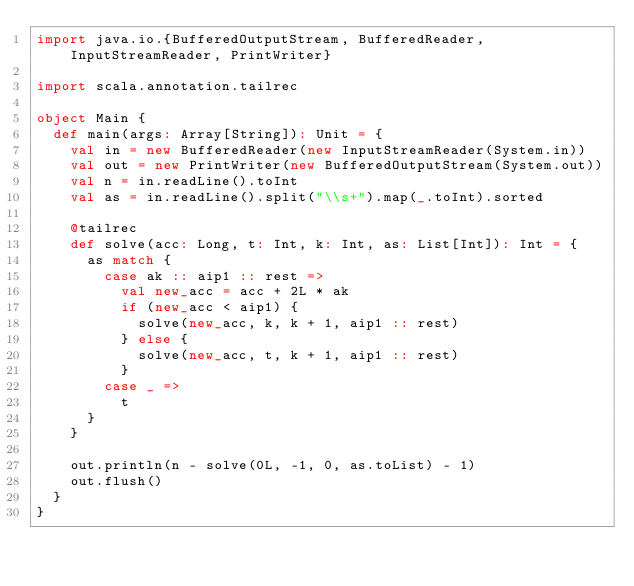<code> <loc_0><loc_0><loc_500><loc_500><_Scala_>import java.io.{BufferedOutputStream, BufferedReader, InputStreamReader, PrintWriter}

import scala.annotation.tailrec

object Main {
  def main(args: Array[String]): Unit = {
    val in = new BufferedReader(new InputStreamReader(System.in))
    val out = new PrintWriter(new BufferedOutputStream(System.out))
    val n = in.readLine().toInt
    val as = in.readLine().split("\\s+").map(_.toInt).sorted

    @tailrec
    def solve(acc: Long, t: Int, k: Int, as: List[Int]): Int = {
      as match {
        case ak :: aip1 :: rest =>
          val new_acc = acc + 2L * ak
          if (new_acc < aip1) {
            solve(new_acc, k, k + 1, aip1 :: rest)
          } else {
            solve(new_acc, t, k + 1, aip1 :: rest)
          }
        case _ =>
          t
      }
    }

    out.println(n - solve(0L, -1, 0, as.toList) - 1)
    out.flush()
  }
}
</code> 